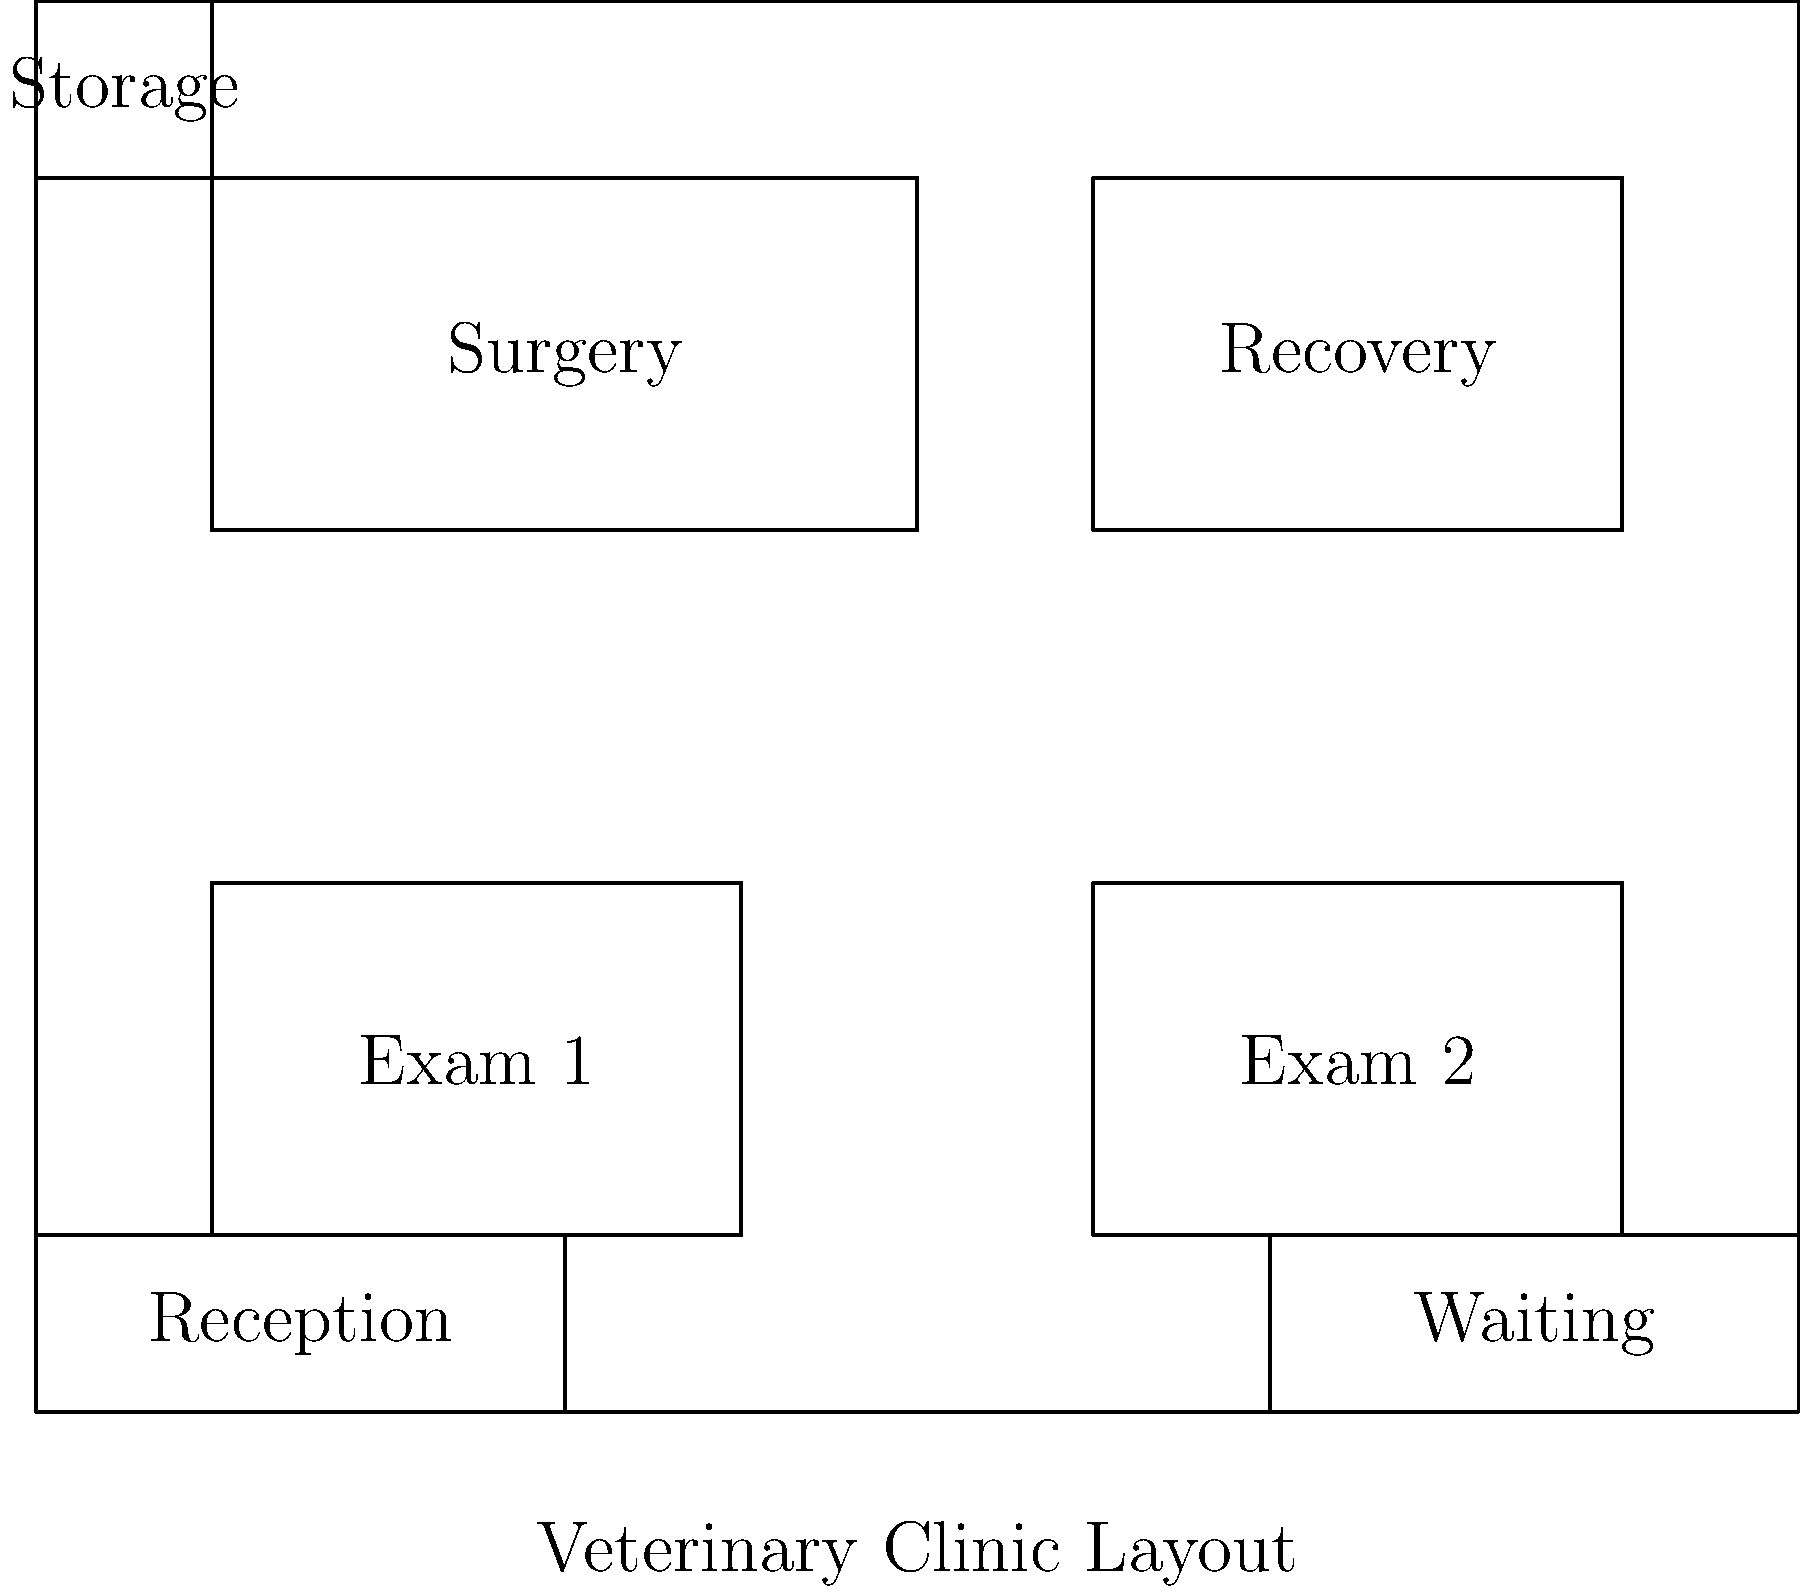Based on the diagram of the optimal layout for a veterinary clinic within a private zoo, what is the total number of distinct functional areas depicted? To determine the total number of distinct functional areas in the veterinary clinic layout, let's identify each area step-by-step:

1. Examination Rooms: There are two examination rooms labeled "Exam 1" and "Exam 2".
2. Surgery Room: A dedicated area for surgical procedures.
3. Recovery Area: A space for animals to recover post-surgery or treatment.
4. Reception: The front desk area for check-ins and administrative tasks.
5. Waiting Area: A space for zoo staff or animal handlers to wait.
6. Storage: A small area designated for storing supplies and equipment.

Each of these areas serves a distinct function within the veterinary clinic. While there are two examination rooms, they serve the same function and are thus counted as one distinct functional area.

Therefore, the total count of distinct functional areas is 6.
Answer: 6 